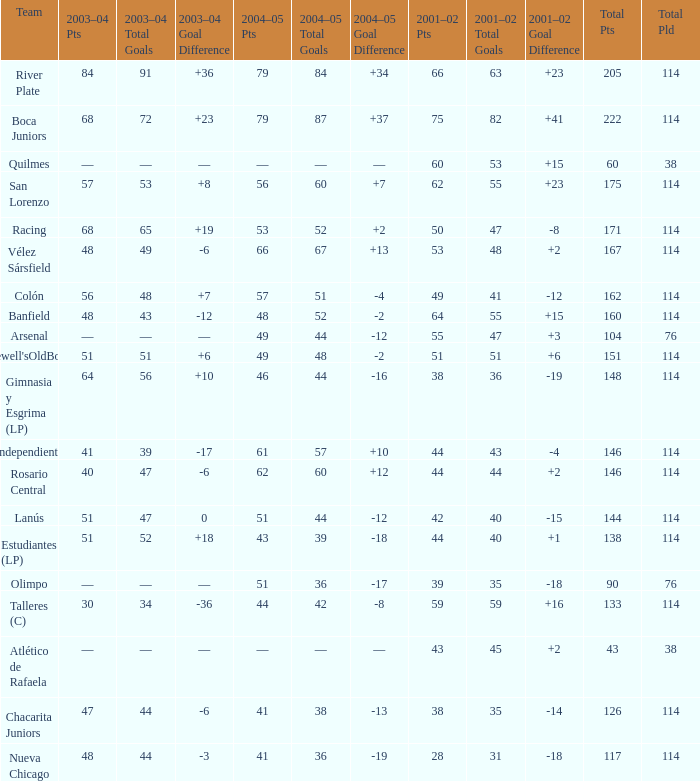Which Total Pts have a 2001–02 Pts smaller than 38? 117.0. 